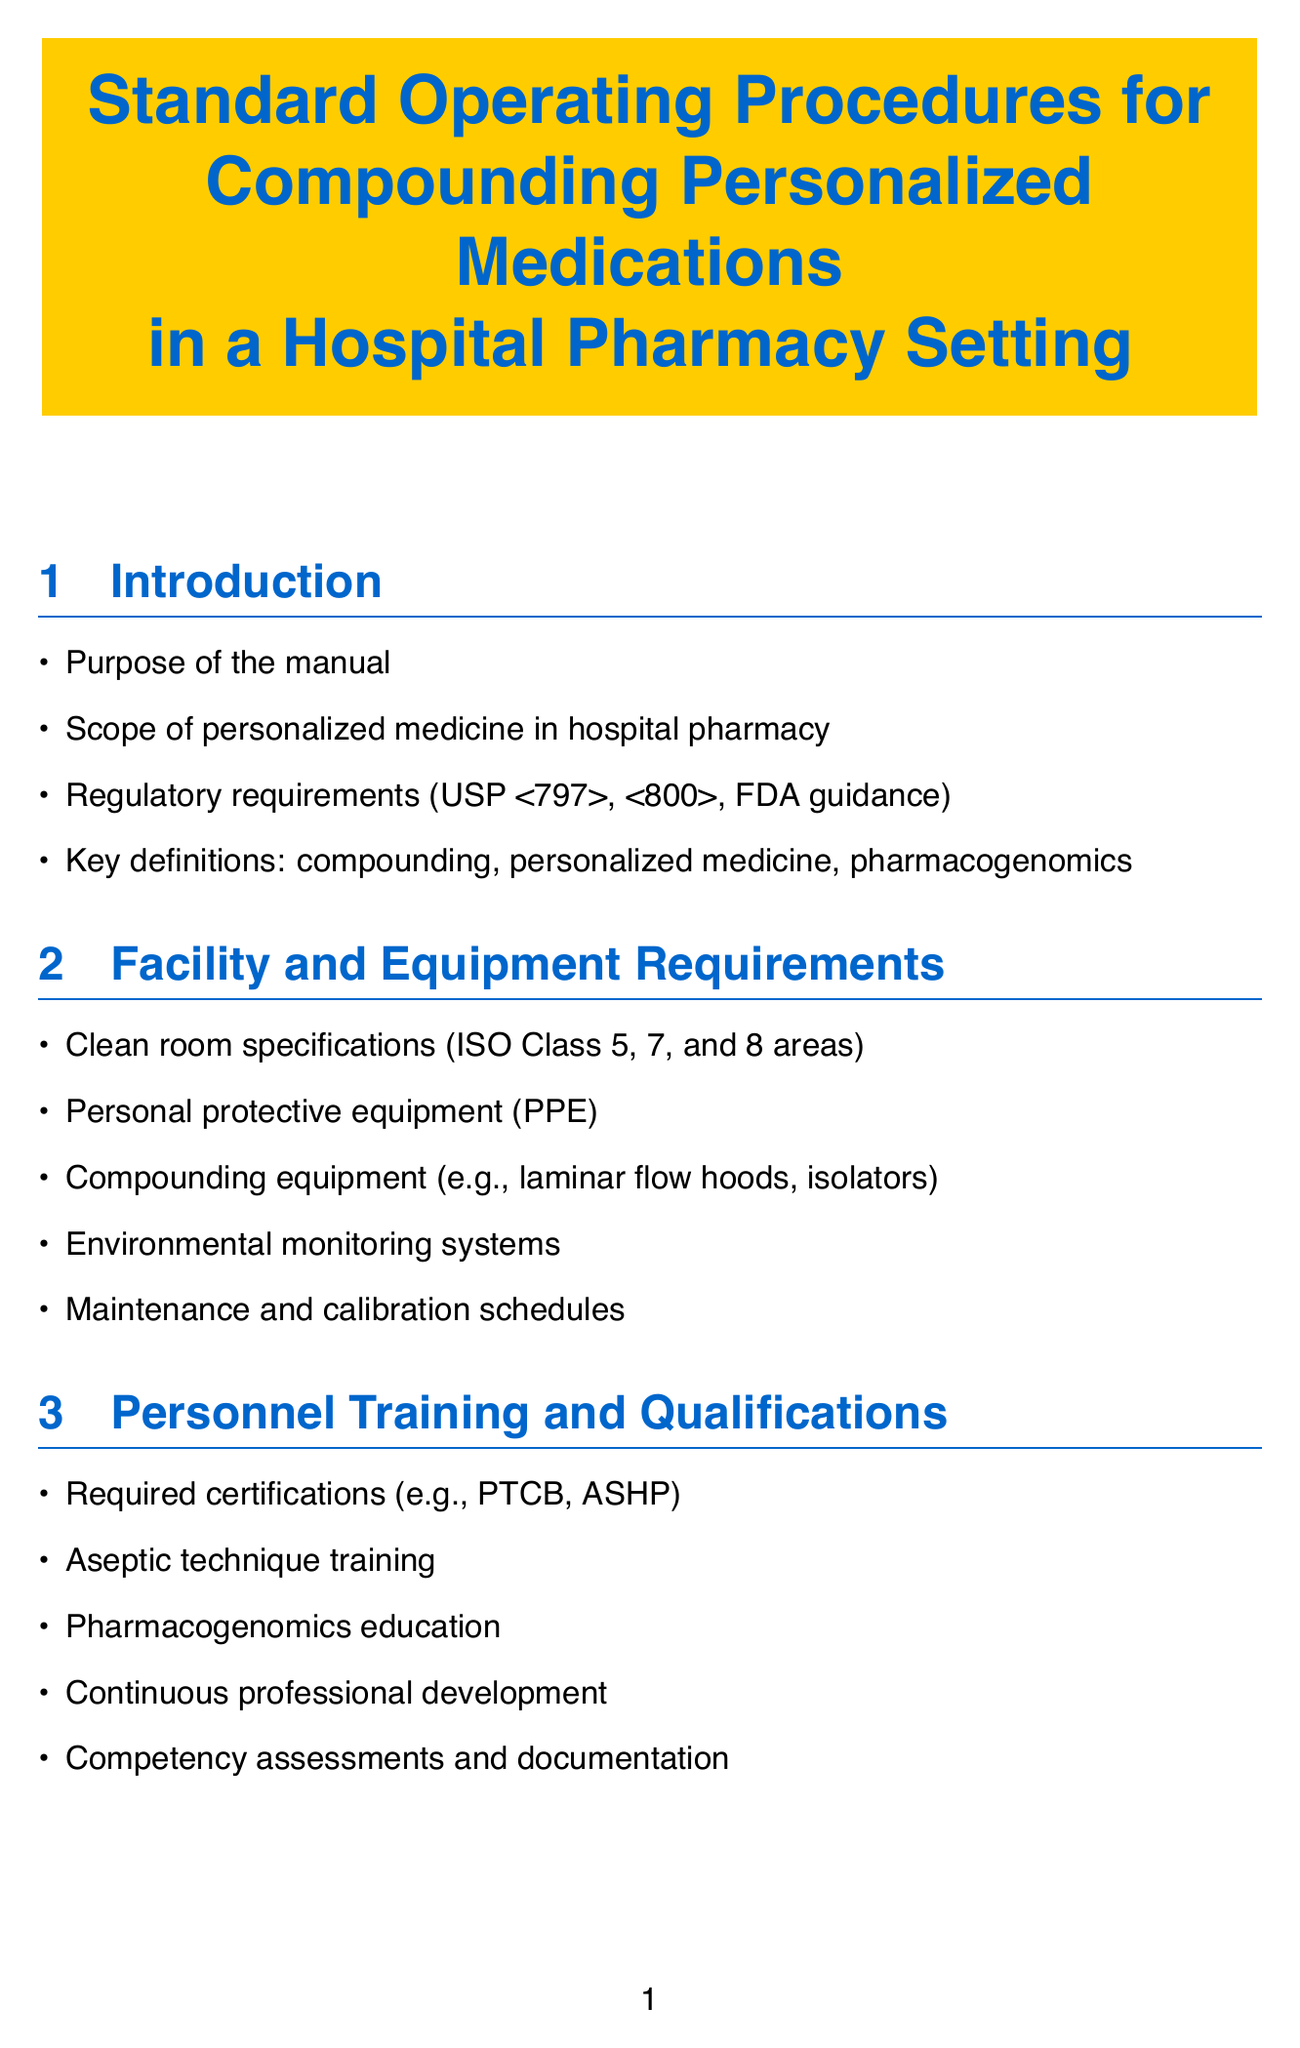What is the purpose of the manual? The purpose of the manual is stated in the introduction section to guide hospital pharmacists in compounding personalized medications.
Answer: Purpose of the manual What certifications are required for personnel? The certifications required for personnel are listed in the personnel training and qualifications section.
Answer: PTCB, ASHP What class specifications are needed for clean rooms? The clean room specifications are noted in the facility and equipment requirements section concerning ISO standards.
Answer: ISO Class 5, 7, and 8 What is the focus of the specific compounding procedures? The specific compounding procedures section includes various personalized medication protocols unique to individual patient needs.
Answer: Personalized chemotherapy protocols What type of software is recommended for pharmacogenomic decision support? The technology and software section highlights the use of specific software designed to assist with pharmacogenomics.
Answer: YouScript, GeneSight What is an example of a factor considered in patient assessment? In the patient assessment and prescription evaluation section, a key factor to evaluate a patient is mentioned for optimal medication therapy.
Answer: Pharmacogenomic test results How is documentation maintained for regulatory compliance? The documentation and record-keeping section outlines the types of logs and records necessary for adhering to regulatory standards.
Answer: Regulatory compliance documentation What is the main goal of continuous improvement initiatives? The continuous improvement and research section describes the intent behind these initiatives in pharmacy practice.
Answer: Process improvement initiatives 